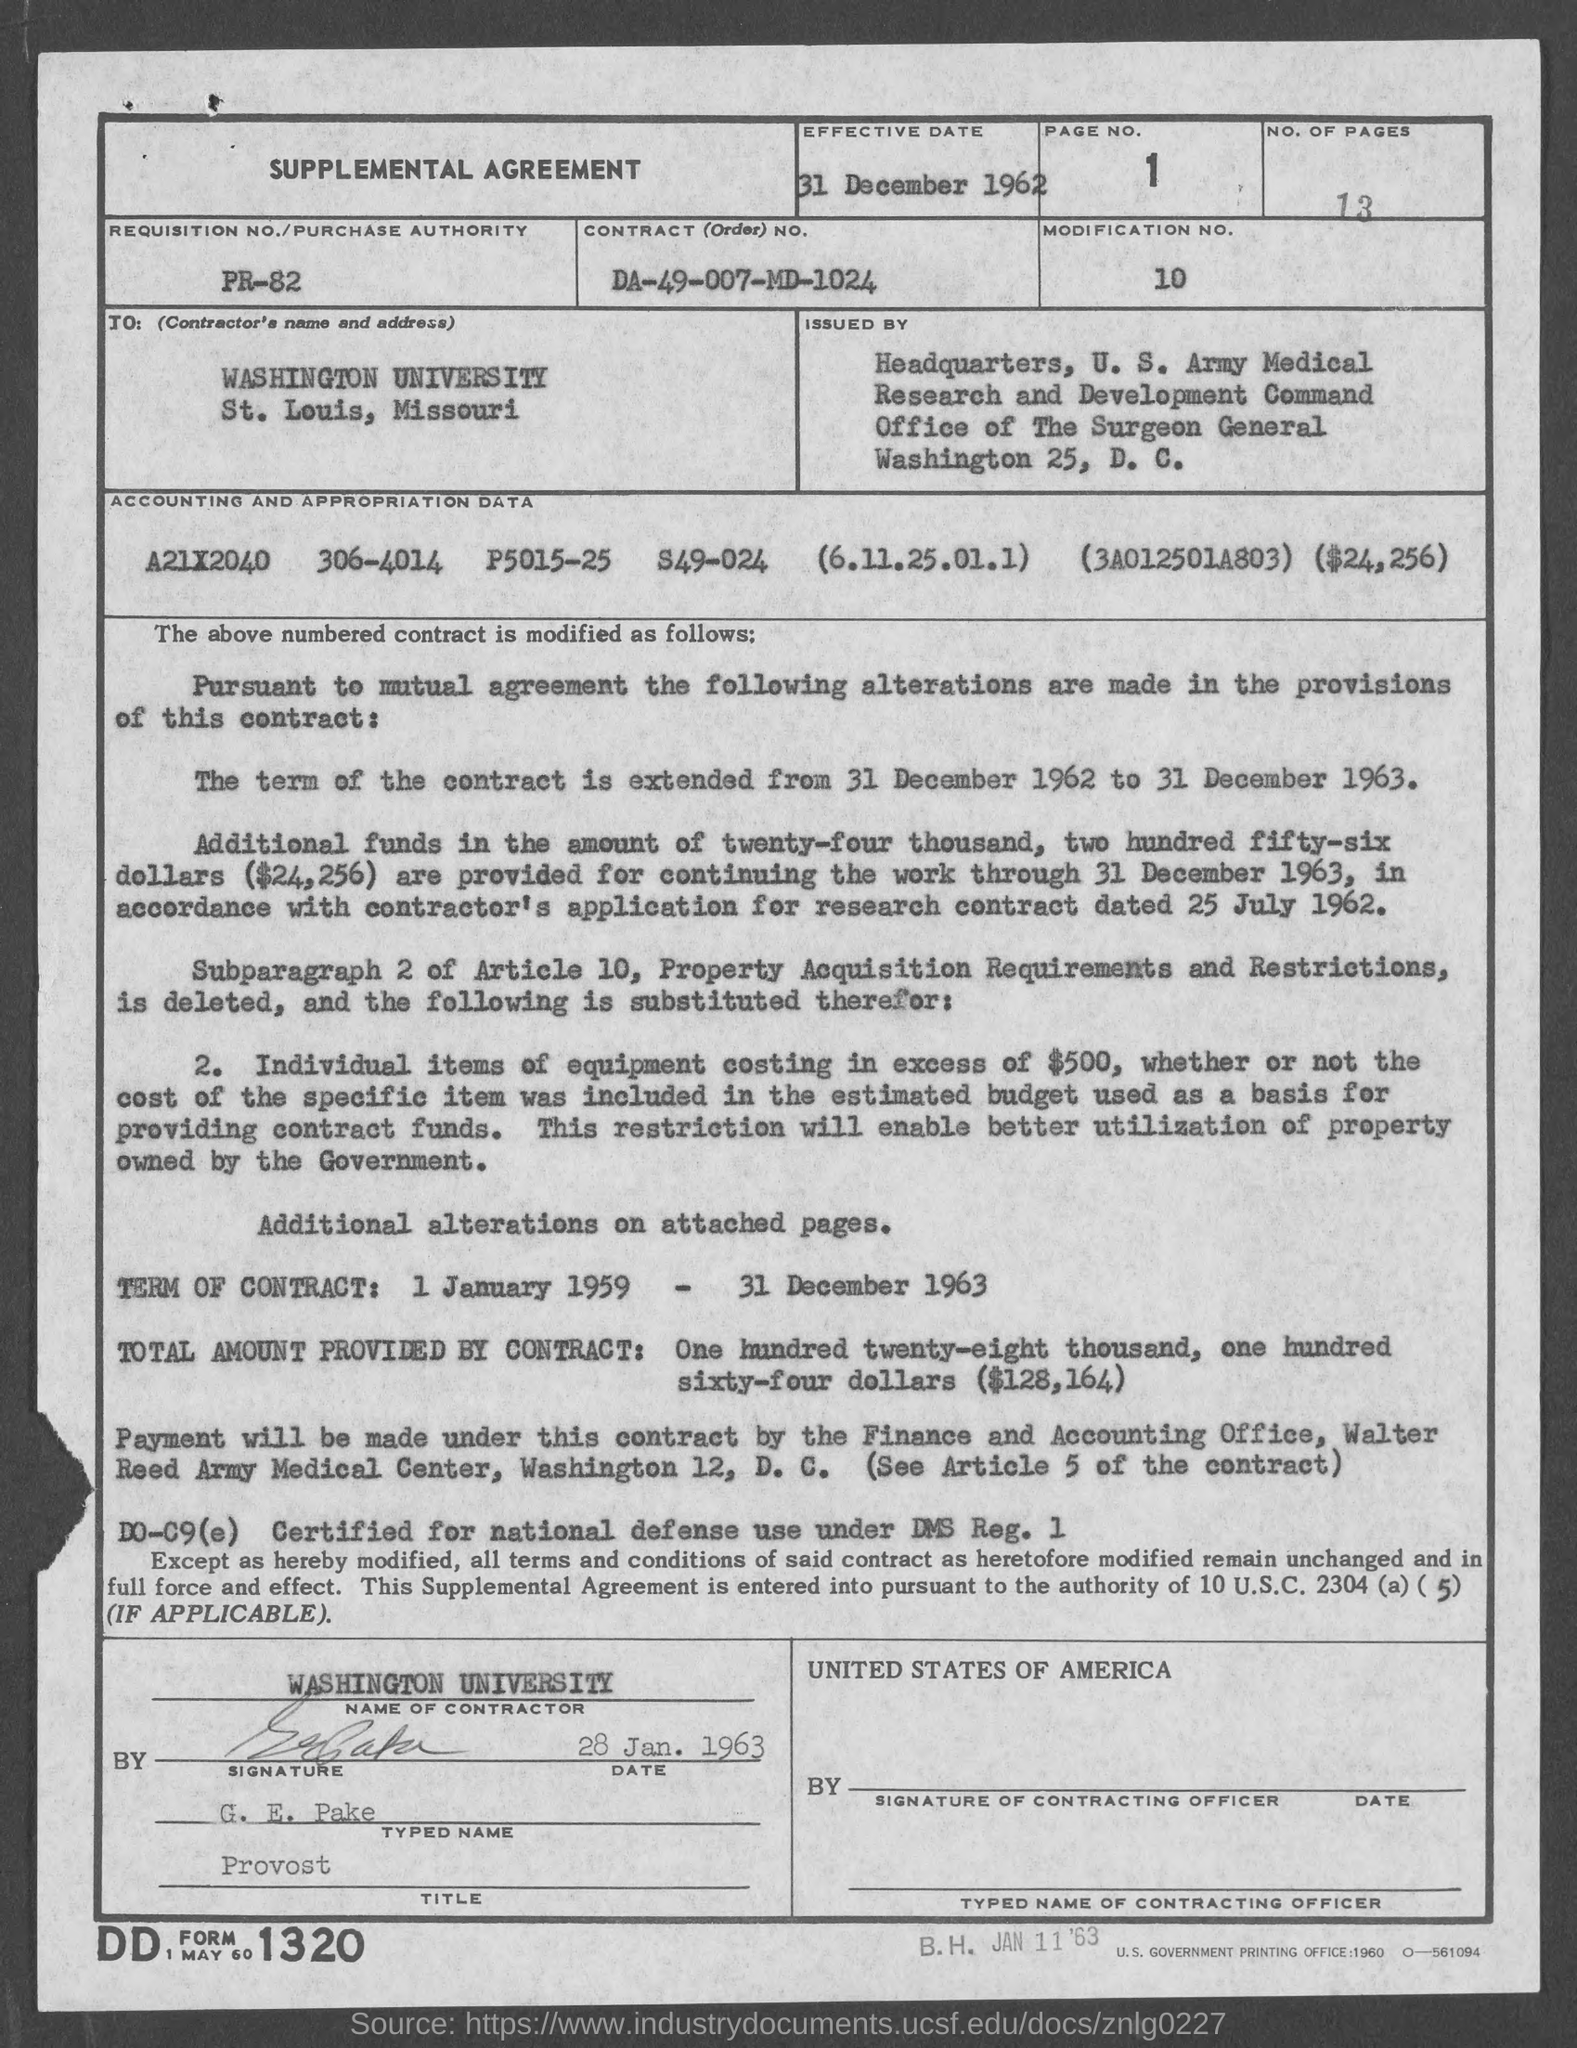What type of documentation is this?
Your response must be concise. SUPPLEMENTAL AGREEMENT. What is the effective date?
Offer a terse response. 31 December 1962. What is the page number on this document?
Provide a succinct answer. 1. How many pages are mentioned?
Ensure brevity in your answer.  13. What is the REQUISITION NO./PURCHASE AUTHORITY?
Offer a terse response. PR-82. What is the CONTRACT (Order) NO.?
Give a very brief answer. DA-49-007-MD-1024. What is the MODIFICATION NO.?
Keep it short and to the point. 10. Who is the contractor?
Your answer should be compact. Washington University. What is the term of the contract?
Make the answer very short. 1 January 1959 - 31 December 1963. 